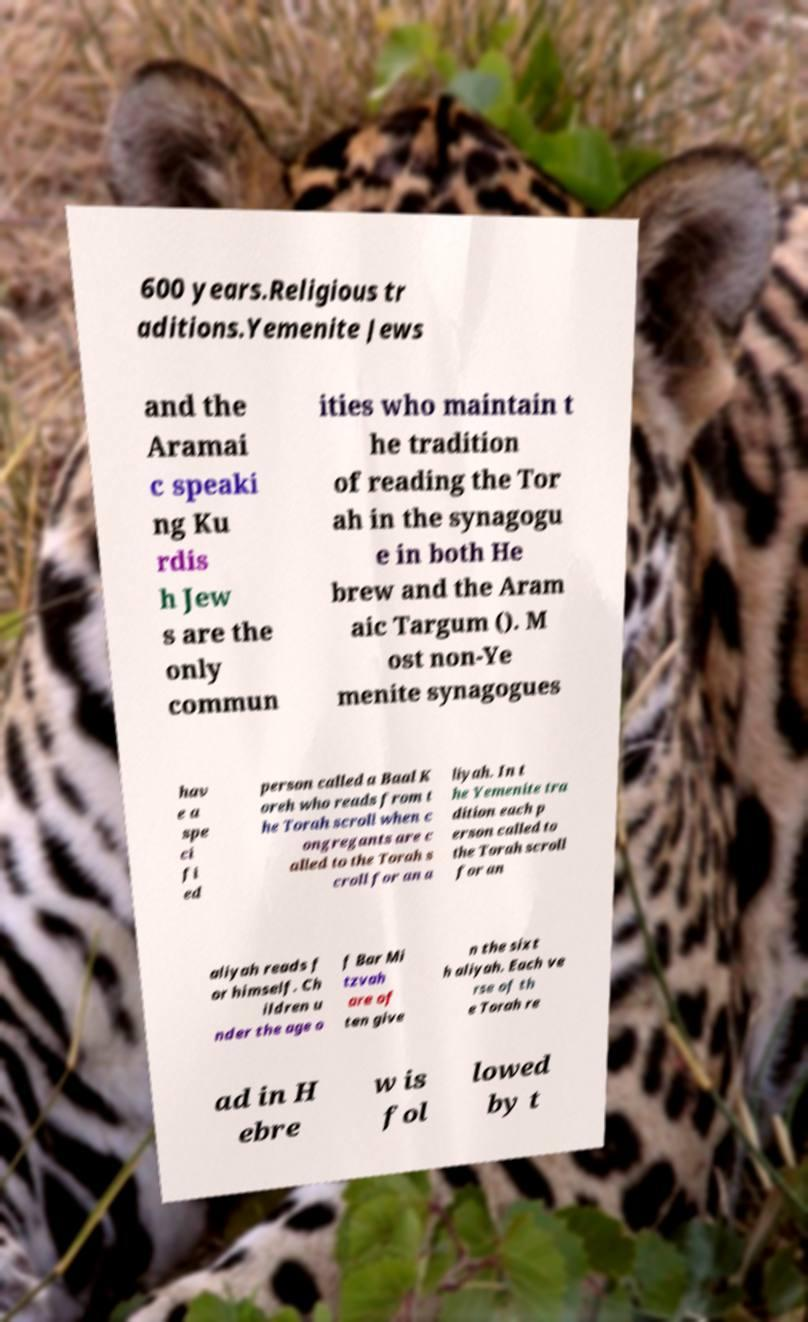For documentation purposes, I need the text within this image transcribed. Could you provide that? 600 years.Religious tr aditions.Yemenite Jews and the Aramai c speaki ng Ku rdis h Jew s are the only commun ities who maintain t he tradition of reading the Tor ah in the synagogu e in both He brew and the Aram aic Targum (). M ost non-Ye menite synagogues hav e a spe ci fi ed person called a Baal K oreh who reads from t he Torah scroll when c ongregants are c alled to the Torah s croll for an a liyah. In t he Yemenite tra dition each p erson called to the Torah scroll for an aliyah reads f or himself. Ch ildren u nder the age o f Bar Mi tzvah are of ten give n the sixt h aliyah. Each ve rse of th e Torah re ad in H ebre w is fol lowed by t 